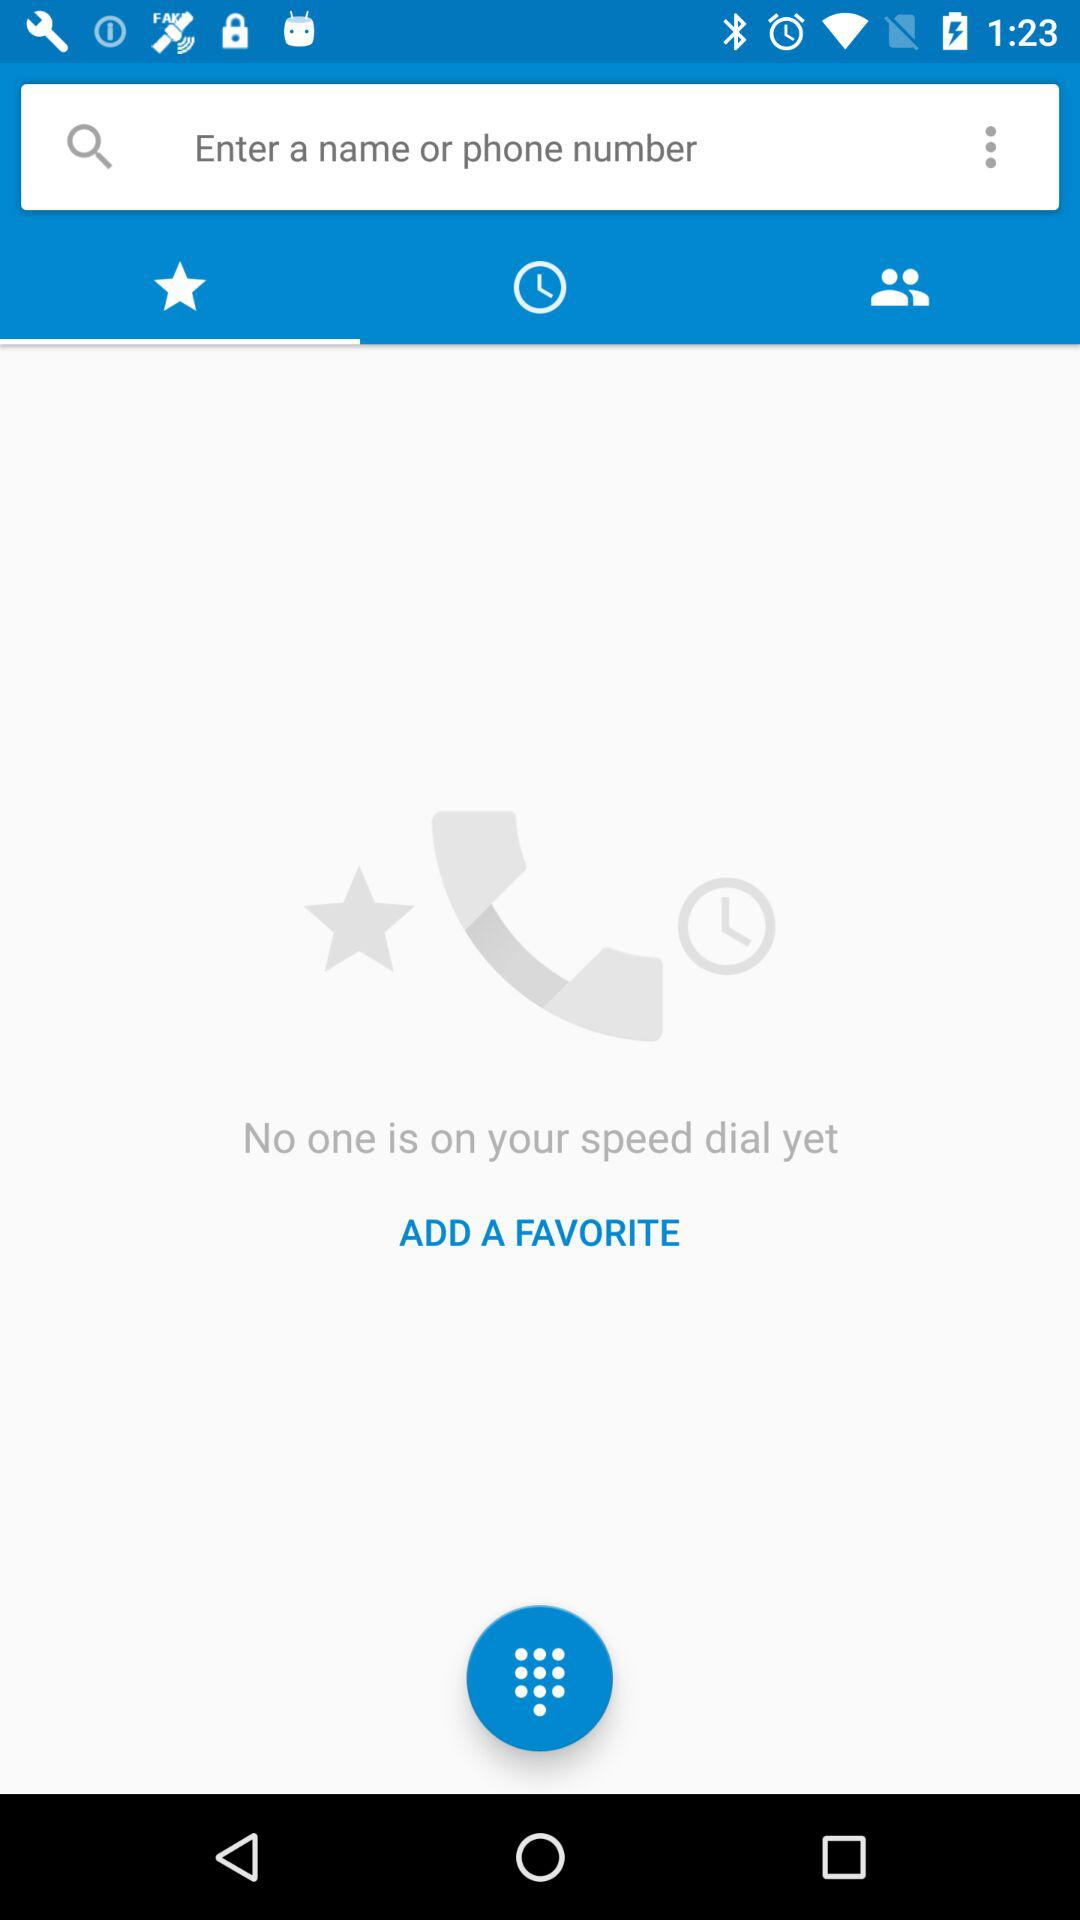Which tab is selected? The selected tab is "Favorite". 